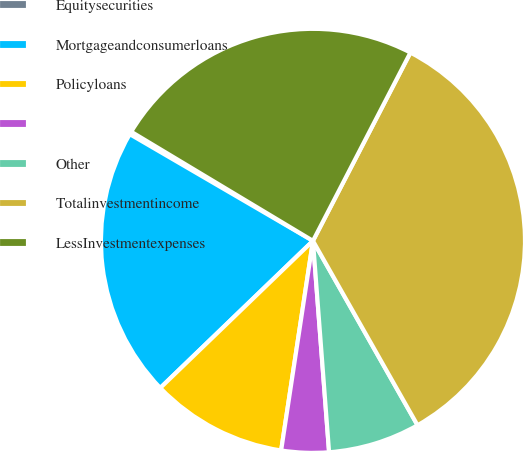<chart> <loc_0><loc_0><loc_500><loc_500><pie_chart><fcel>Equitysecurities<fcel>Mortgageandconsumerloans<fcel>Policyloans<fcel>Unnamed: 3<fcel>Other<fcel>Totalinvestmentincome<fcel>LessInvestmentexpenses<nl><fcel>0.21%<fcel>20.6%<fcel>10.4%<fcel>3.61%<fcel>7.0%<fcel>34.19%<fcel>24.0%<nl></chart> 